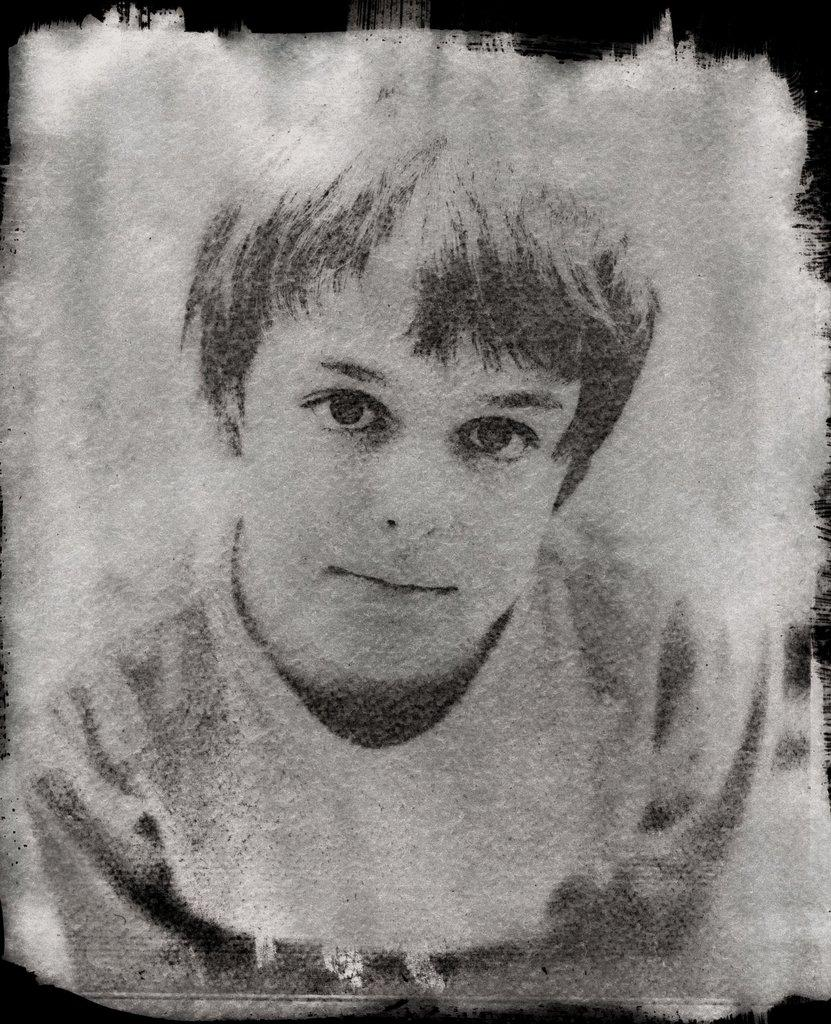What is the color scheme of the image? The image is black and white. What is the main subject in the foreground of the image? There is an image of a boy in the foreground. Are there any specific features of the image's borders? The image has black borders. How many rabbits can be seen in the image? There are no rabbits present in the image. What is the elevation of the railway in the image? There is no railway present in the image. 